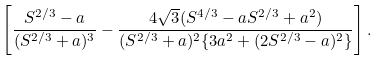Convert formula to latex. <formula><loc_0><loc_0><loc_500><loc_500>\left [ \frac { S ^ { 2 / 3 } - a } { ( S ^ { 2 / 3 } + a ) ^ { 3 } } - \frac { 4 \sqrt { 3 } ( S ^ { 4 / 3 } - a S ^ { 2 / 3 } + a ^ { 2 } ) } { ( S ^ { 2 / 3 } + a ) ^ { 2 } \{ 3 a ^ { 2 } + ( 2 S ^ { 2 / 3 } - a ) ^ { 2 } \} } \right ] .</formula> 